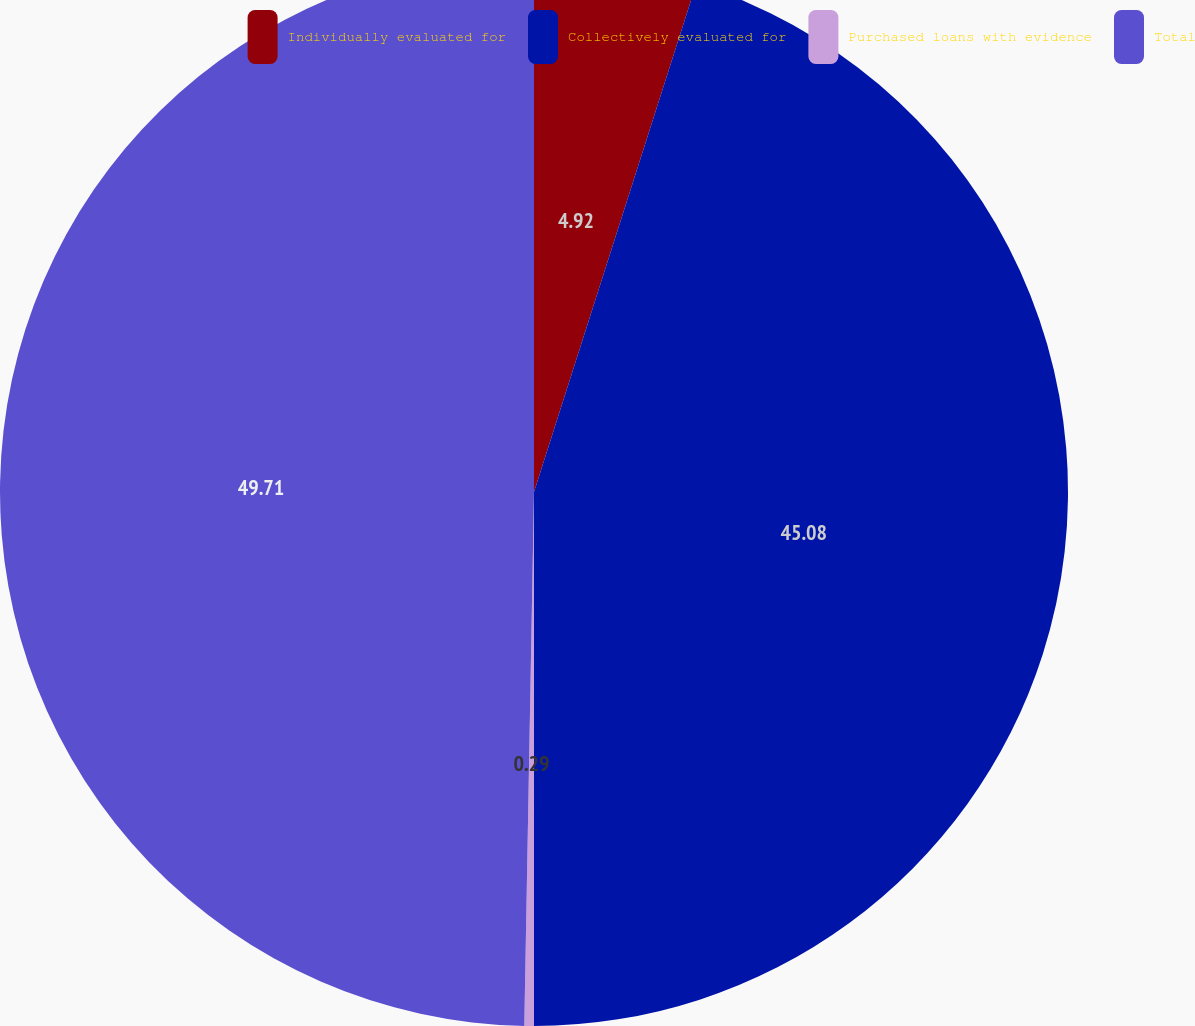Convert chart to OTSL. <chart><loc_0><loc_0><loc_500><loc_500><pie_chart><fcel>Individually evaluated for<fcel>Collectively evaluated for<fcel>Purchased loans with evidence<fcel>Total<nl><fcel>4.92%<fcel>45.08%<fcel>0.29%<fcel>49.71%<nl></chart> 